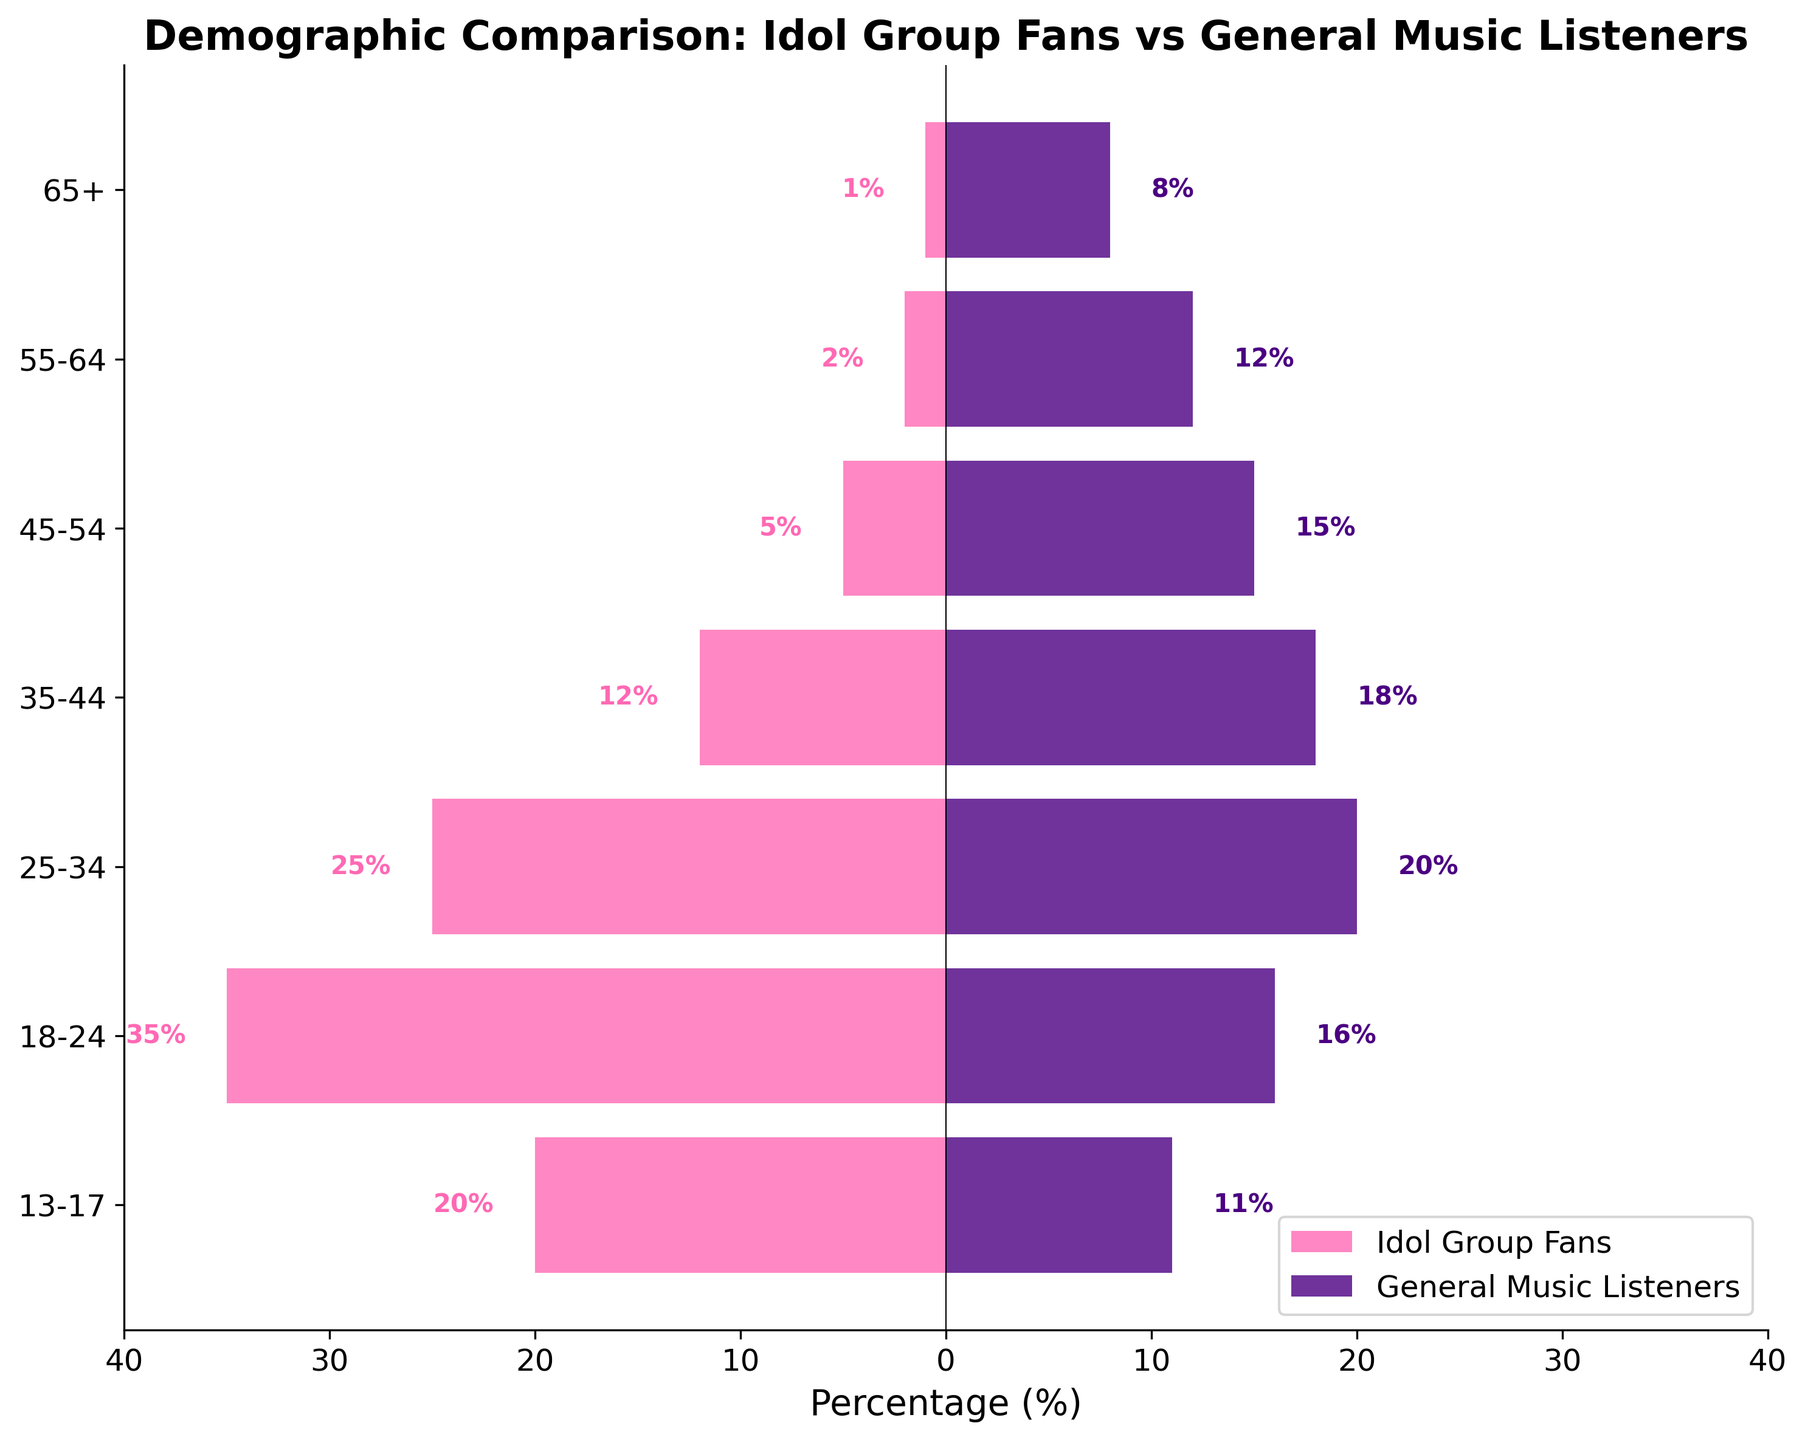What's the title of the figure? The title is usually displayed at the top of the figure. In this case, it should be clearly indicated.
Answer: Demographic Comparison: Idol Group Fans vs General Music Listeners What percentage of Idol Group Fans falls in the 25-34 age group? Locate the 25-34 age group on the y-axis and then find the corresponding bar for Idol Group Fans, which is represented by the color pink. The percentage is written near the bar.
Answer: 25% What is the largest age group among Idol Group Fans? Compare all the percentage values associated with Idol Group Fans and find the maximum value which identifies the largest age group. The specific percentage also validates this group.
Answer: 18-24 (35%) Which age group has the closest percentage of Idol Group Fans and General Music Listeners? Compare the percentages of both groups for each age category and find the closest values.
Answer: 25-34 What is the difference in percentage between General Music Listeners and Idol Group Fans in the 65+ age group? Identify the percentages for General Music Listeners and Idol Group Fans in the 65+ age group and compute the difference.
Answer: 7% Which age group has the smallest percentage of Idol Group Fans? Locate the smallest value in the percentage column for Idol Group Fans and identify the corresponding age group.
Answer: 65+ (1%) How does the distribution of General Music Listeners aged 35-44 compare to Idol Group Fans of the same group? Compare the percentage values of General Music Listeners and Idol Group Fans specifically for the 35-44 age group.
Answer: General Music Listeners: 18%, Idol Group Fans: 12% What is the total percentage of Idol Group Fans aged below 25? Sum the percentages of the 13-17 and 18-24 age groups to find the total percentage of Idol Group Fans aged below 25.
Answer: 55% Between the 18-24 and 25-34 age groups, which has more General Music Listeners? Compare the percentages of General Music Listeners in both the 18-24 and 25-34 age groups to determine which group has a higher percentage.
Answer: 25-34 Which age group shows the greatest difference in percentages between Idol Group Fans and General Music Listeners? Calculate the percentage differences between the Idol Group Fans and General Music Listeners for each age group and identify the maximum difference.
Answer: 45-54 (10%) 